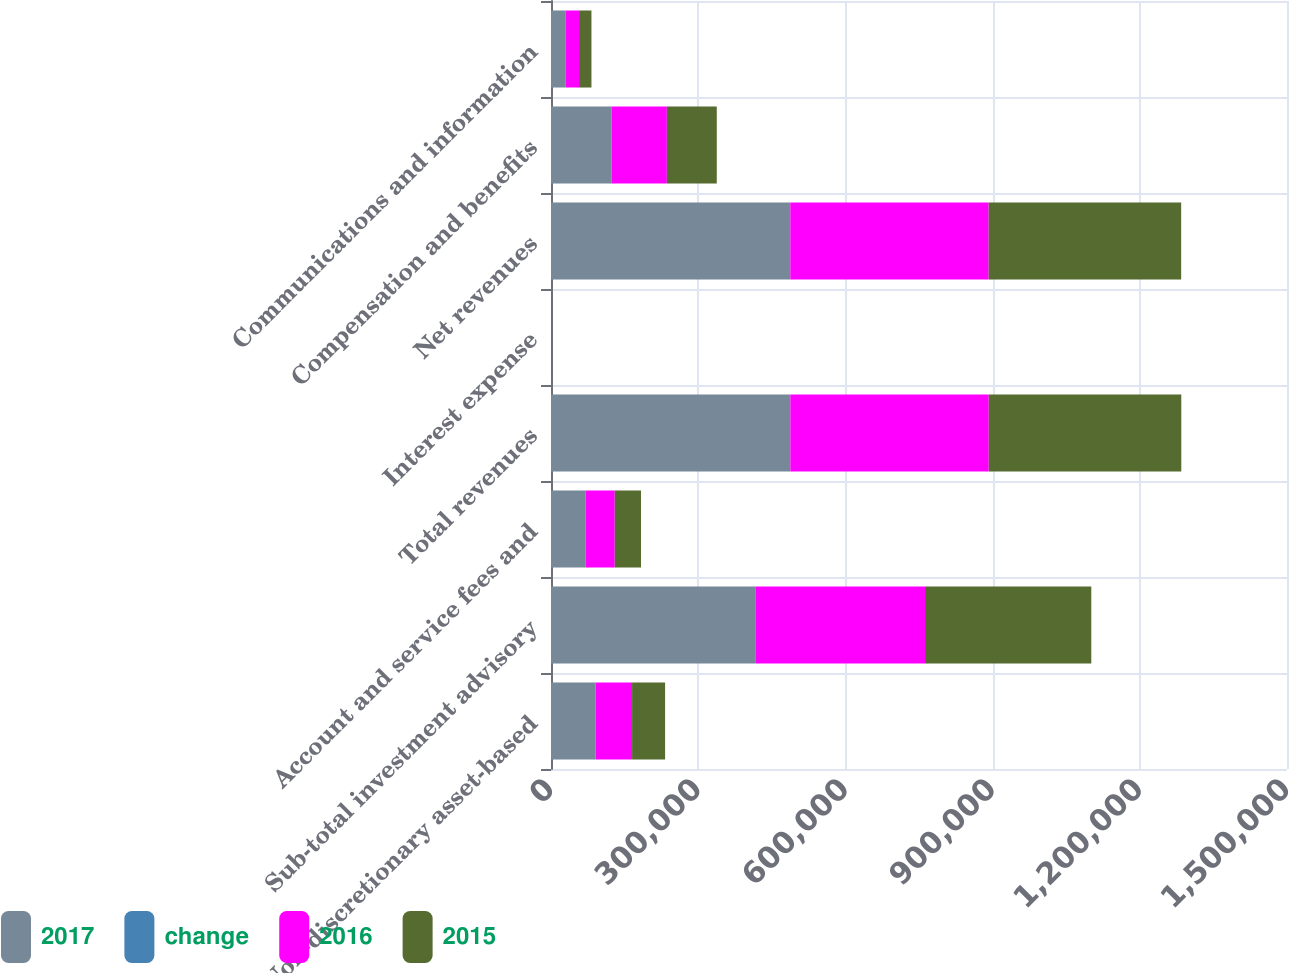Convert chart. <chart><loc_0><loc_0><loc_500><loc_500><stacked_bar_chart><ecel><fcel>Non-discretionary asset-based<fcel>Sub-total investment advisory<fcel>Account and service fees and<fcel>Total revenues<fcel>Interest expense<fcel>Net revenues<fcel>Compensation and benefits<fcel>Communications and information<nl><fcel>2017<fcel>91087<fcel>417492<fcel>70243<fcel>487735<fcel>77<fcel>487658<fcel>123119<fcel>30109<nl><fcel>change<fcel>23<fcel>21<fcel>18<fcel>21<fcel>7<fcel>21<fcel>9<fcel>11<nl><fcel>2016<fcel>74130<fcel>344753<fcel>59668<fcel>404421<fcel>72<fcel>404349<fcel>112998<fcel>27027<nl><fcel>2015<fcel>67286<fcel>338895<fcel>53483<fcel>392378<fcel>77<fcel>392301<fcel>101723<fcel>25286<nl></chart> 